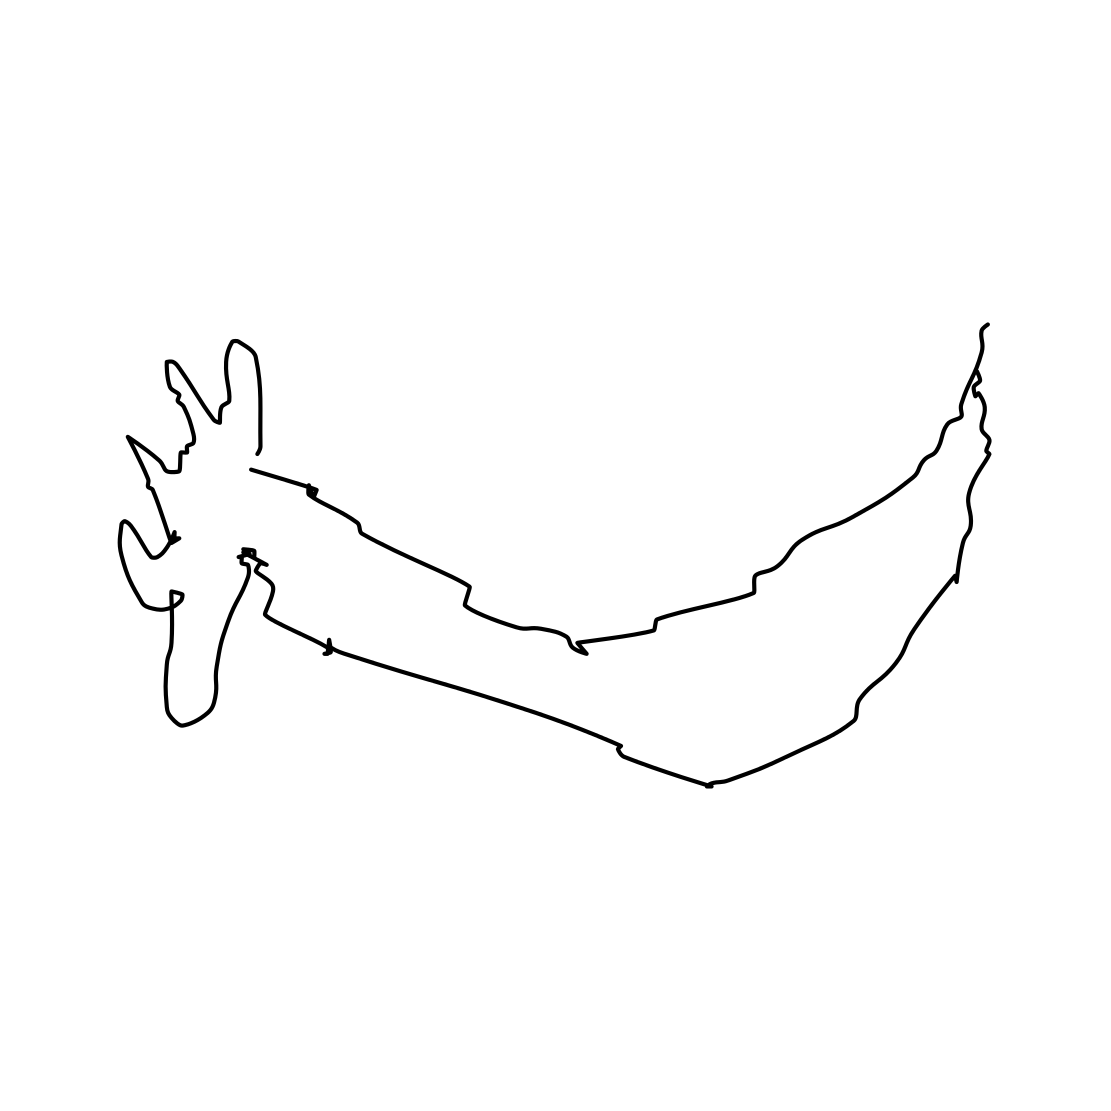What emotions does this illustration evoke? The illustration with its clean and uncluttered design might evoke a sense of calm and tranquility. Its minimalist nature could also inspire feelings of elegance and simplicity. For those who love nature or animals, it might also evoke a sense of admiration or connection to wildlife. 